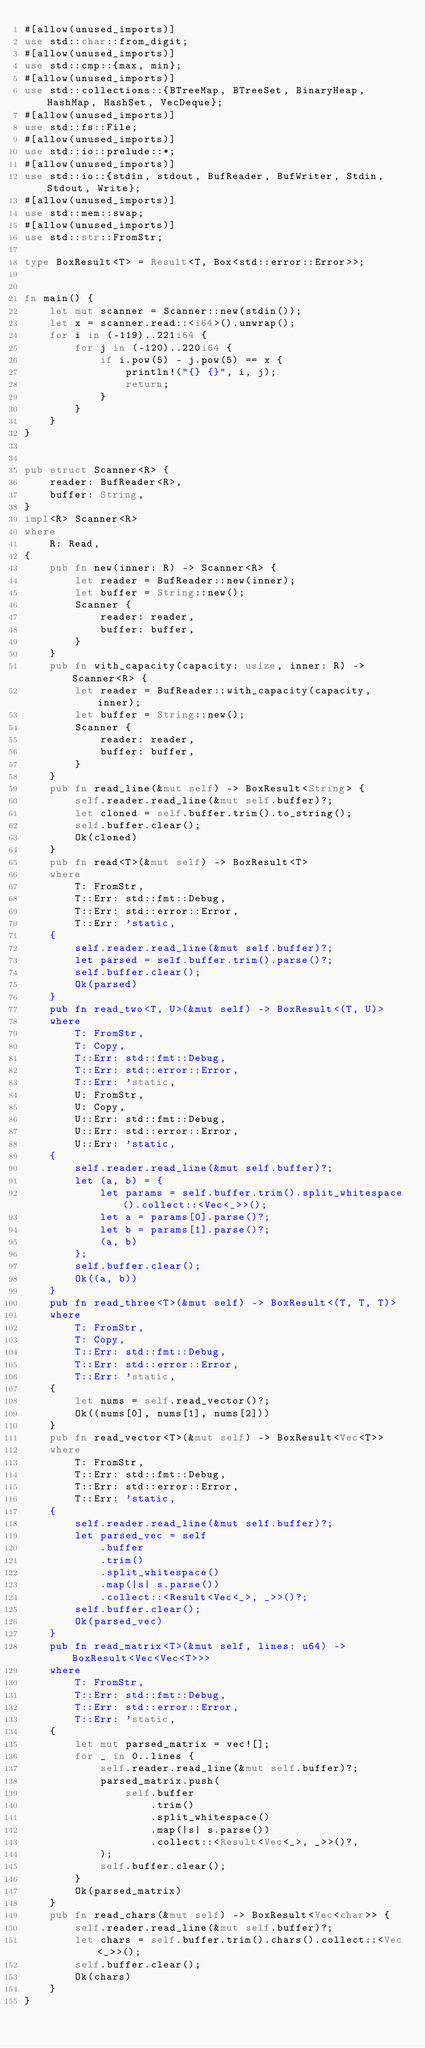<code> <loc_0><loc_0><loc_500><loc_500><_Rust_>#[allow(unused_imports)]
use std::char::from_digit;
#[allow(unused_imports)]
use std::cmp::{max, min};
#[allow(unused_imports)]
use std::collections::{BTreeMap, BTreeSet, BinaryHeap, HashMap, HashSet, VecDeque};
#[allow(unused_imports)]
use std::fs::File;
#[allow(unused_imports)]
use std::io::prelude::*;
#[allow(unused_imports)]
use std::io::{stdin, stdout, BufReader, BufWriter, Stdin, Stdout, Write};
#[allow(unused_imports)]
use std::mem::swap;
#[allow(unused_imports)]
use std::str::FromStr;

type BoxResult<T> = Result<T, Box<std::error::Error>>;


fn main() {
    let mut scanner = Scanner::new(stdin());
    let x = scanner.read::<i64>().unwrap();
    for i in (-119)..221i64 {
        for j in (-120)..220i64 {
            if i.pow(5) - j.pow(5) == x {
                println!("{} {}", i, j);
                return;
            }
        }
    }
}


pub struct Scanner<R> {
    reader: BufReader<R>,
    buffer: String,
}
impl<R> Scanner<R>
where
    R: Read,
{
    pub fn new(inner: R) -> Scanner<R> {
        let reader = BufReader::new(inner);
        let buffer = String::new();
        Scanner {
            reader: reader,
            buffer: buffer,
        }
    }
    pub fn with_capacity(capacity: usize, inner: R) -> Scanner<R> {
        let reader = BufReader::with_capacity(capacity, inner);
        let buffer = String::new();
        Scanner {
            reader: reader,
            buffer: buffer,
        }
    }
    pub fn read_line(&mut self) -> BoxResult<String> {
        self.reader.read_line(&mut self.buffer)?;
        let cloned = self.buffer.trim().to_string();
        self.buffer.clear();
        Ok(cloned)
    }
    pub fn read<T>(&mut self) -> BoxResult<T>
    where
        T: FromStr,
        T::Err: std::fmt::Debug,
        T::Err: std::error::Error,
        T::Err: 'static,
    {
        self.reader.read_line(&mut self.buffer)?;
        let parsed = self.buffer.trim().parse()?;
        self.buffer.clear();
        Ok(parsed)
    }
    pub fn read_two<T, U>(&mut self) -> BoxResult<(T, U)>
    where
        T: FromStr,
        T: Copy,
        T::Err: std::fmt::Debug,
        T::Err: std::error::Error,
        T::Err: 'static,
        U: FromStr,
        U: Copy,
        U::Err: std::fmt::Debug,
        U::Err: std::error::Error,
        U::Err: 'static,
    {
        self.reader.read_line(&mut self.buffer)?;
        let (a, b) = {
            let params = self.buffer.trim().split_whitespace().collect::<Vec<_>>();
            let a = params[0].parse()?;
            let b = params[1].parse()?;
            (a, b)
        };
        self.buffer.clear();
        Ok((a, b))
    }
    pub fn read_three<T>(&mut self) -> BoxResult<(T, T, T)>
    where
        T: FromStr,
        T: Copy,
        T::Err: std::fmt::Debug,
        T::Err: std::error::Error,
        T::Err: 'static,
    {
        let nums = self.read_vector()?;
        Ok((nums[0], nums[1], nums[2]))
    }
    pub fn read_vector<T>(&mut self) -> BoxResult<Vec<T>>
    where
        T: FromStr,
        T::Err: std::fmt::Debug,
        T::Err: std::error::Error,
        T::Err: 'static,
    {
        self.reader.read_line(&mut self.buffer)?;
        let parsed_vec = self
            .buffer
            .trim()
            .split_whitespace()
            .map(|s| s.parse())
            .collect::<Result<Vec<_>, _>>()?;
        self.buffer.clear();
        Ok(parsed_vec)
    }
    pub fn read_matrix<T>(&mut self, lines: u64) -> BoxResult<Vec<Vec<T>>>
    where
        T: FromStr,
        T::Err: std::fmt::Debug,
        T::Err: std::error::Error,
        T::Err: 'static,
    {
        let mut parsed_matrix = vec![];
        for _ in 0..lines {
            self.reader.read_line(&mut self.buffer)?;
            parsed_matrix.push(
                self.buffer
                    .trim()
                    .split_whitespace()
                    .map(|s| s.parse())
                    .collect::<Result<Vec<_>, _>>()?,
            );
            self.buffer.clear();
        }
        Ok(parsed_matrix)
    }
    pub fn read_chars(&mut self) -> BoxResult<Vec<char>> {
        self.reader.read_line(&mut self.buffer)?;
        let chars = self.buffer.trim().chars().collect::<Vec<_>>();
        self.buffer.clear();
        Ok(chars)
    }
}
</code> 